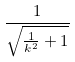Convert formula to latex. <formula><loc_0><loc_0><loc_500><loc_500>\frac { 1 } { \sqrt { \frac { 1 } { k ^ { 2 } } + 1 } }</formula> 